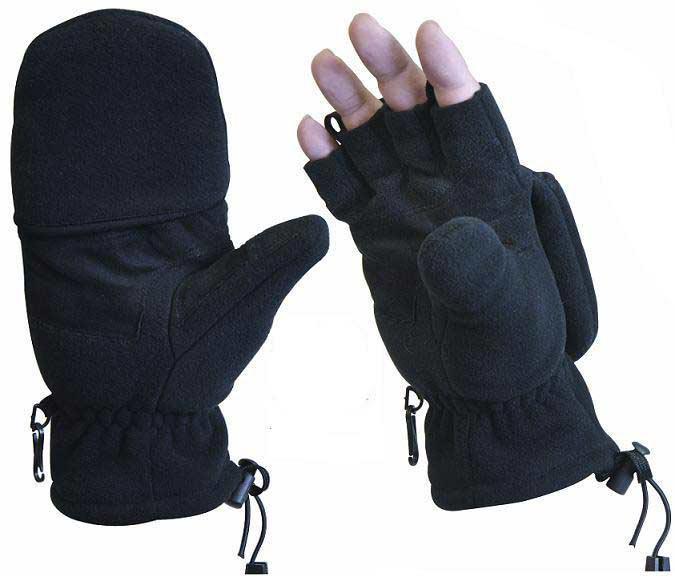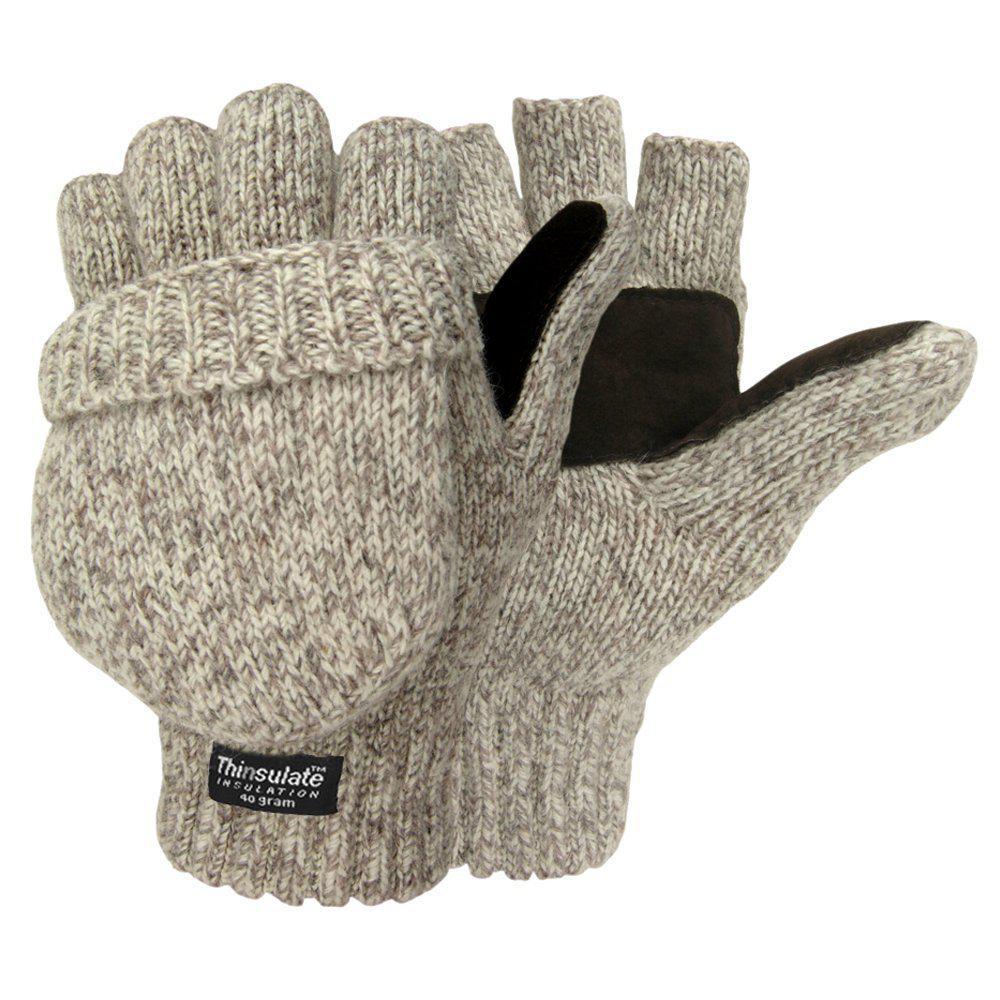The first image is the image on the left, the second image is the image on the right. Considering the images on both sides, is "the gloves on the right don't have cut off fingers" valid? Answer yes or no. No. The first image is the image on the left, the second image is the image on the right. Assess this claim about the two images: "Both gloves have detachable fingers". Correct or not? Answer yes or no. Yes. 